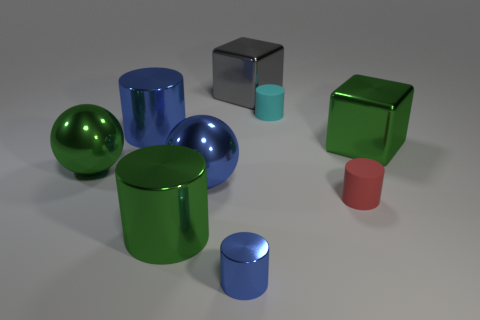Subtract all red rubber cylinders. How many cylinders are left? 4 Subtract 1 cylinders. How many cylinders are left? 4 Subtract all red cylinders. How many cylinders are left? 4 Subtract all gray cylinders. Subtract all yellow cubes. How many cylinders are left? 5 Add 1 red rubber cylinders. How many objects exist? 10 Subtract all spheres. How many objects are left? 7 Subtract 0 brown blocks. How many objects are left? 9 Subtract all small blue metallic cylinders. Subtract all tiny rubber objects. How many objects are left? 6 Add 6 matte objects. How many matte objects are left? 8 Add 8 blue shiny cylinders. How many blue shiny cylinders exist? 10 